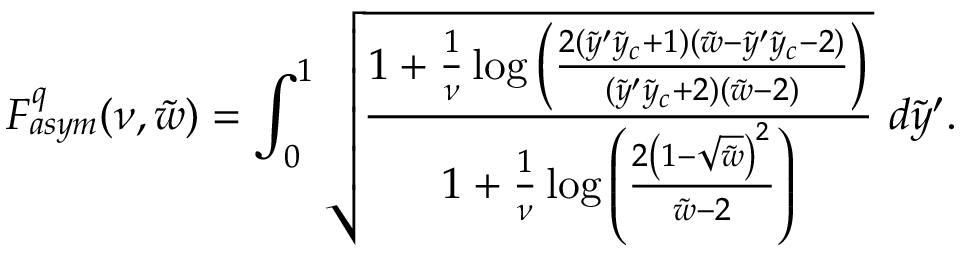<formula> <loc_0><loc_0><loc_500><loc_500>F _ { a s y m } ^ { q } ( \nu , \tilde { w } ) = \int _ { 0 } ^ { 1 } \sqrt { \frac { 1 + \frac { 1 } { \nu } \log \left ( \frac { 2 ( \tilde { y } ^ { \prime } \tilde { y } _ { c } + 1 ) ( \tilde { w } - \tilde { y } ^ { \prime } \tilde { y } _ { c } - 2 ) } { ( \tilde { y } ^ { \prime } \tilde { y } _ { c } + 2 ) ( \tilde { w } - 2 ) } \right ) } { 1 + \frac { 1 } { \nu } \log \left ( \frac { 2 \left ( 1 - \sqrt { \tilde { w } } \right ) ^ { 2 } } { \tilde { w } - 2 } \right ) } } d \tilde { y } ^ { \prime } .</formula> 